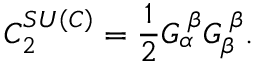Convert formula to latex. <formula><loc_0><loc_0><loc_500><loc_500>C _ { 2 } ^ { S U \left ( C \right ) } = \frac { 1 } { 2 } G _ { \alpha } ^ { \, \beta } G _ { \beta } ^ { \, \beta } .</formula> 